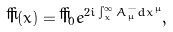Convert formula to latex. <formula><loc_0><loc_0><loc_500><loc_500>\check { T } ( x ) = \check { T } _ { 0 } e ^ { 2 i \int _ { x } ^ { \infty } A _ { \mu } ^ { - } d x ^ { \mu } } ,</formula> 